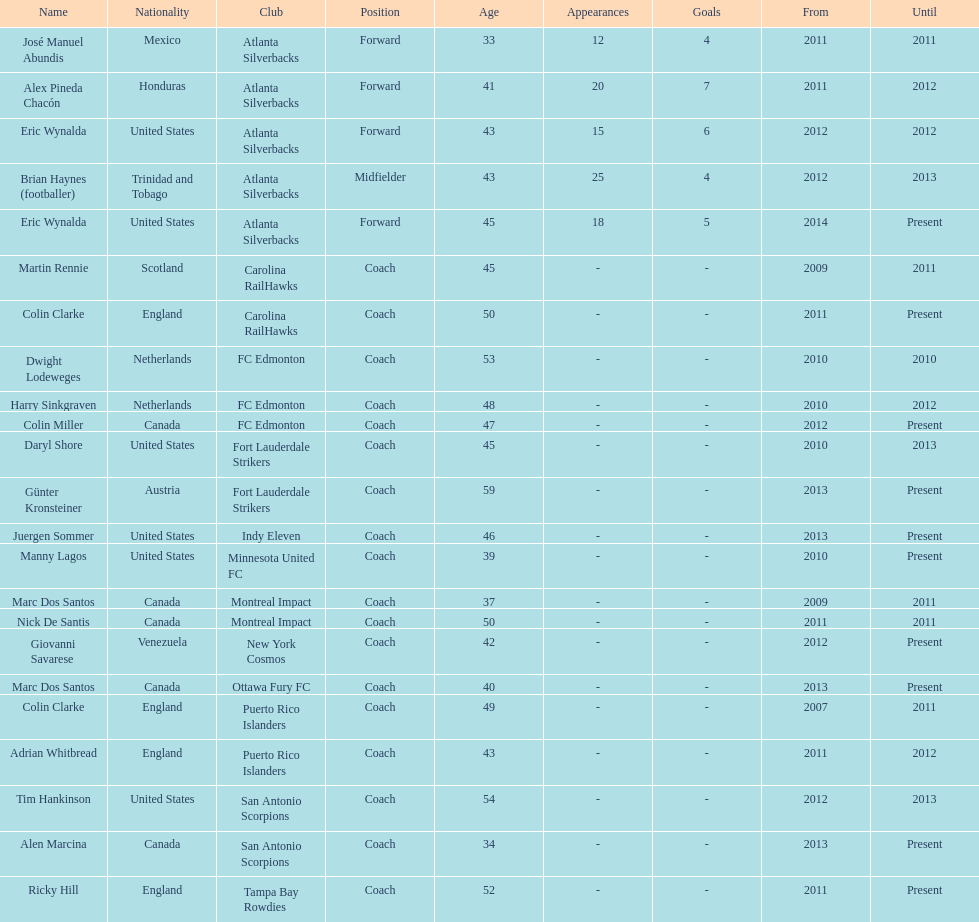What same country did marc dos santos coach as colin miller? Canada. 